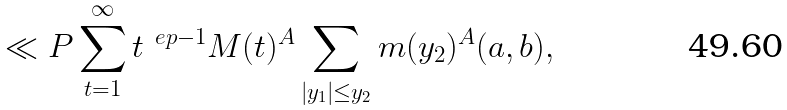<formula> <loc_0><loc_0><loc_500><loc_500>\ll P \sum _ { t = 1 } ^ { \infty } t ^ { \ e p - 1 } M ( t ) ^ { A } \sum _ { | y _ { 1 } | \leq y _ { 2 } } m ( y _ { 2 } ) ^ { A } ( a , b ) ,</formula> 